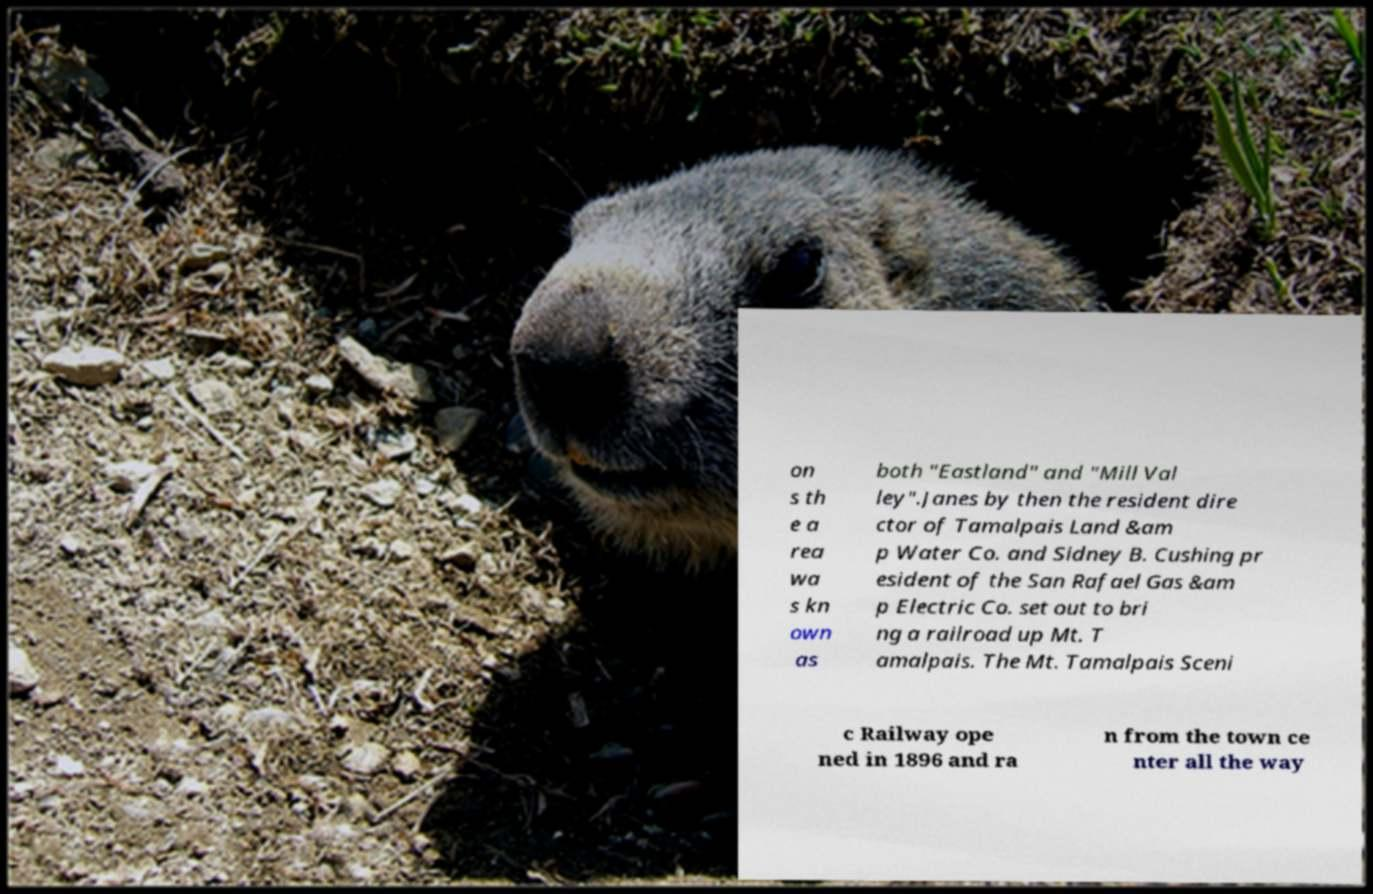Can you accurately transcribe the text from the provided image for me? on s th e a rea wa s kn own as both "Eastland" and "Mill Val ley".Janes by then the resident dire ctor of Tamalpais Land &am p Water Co. and Sidney B. Cushing pr esident of the San Rafael Gas &am p Electric Co. set out to bri ng a railroad up Mt. T amalpais. The Mt. Tamalpais Sceni c Railway ope ned in 1896 and ra n from the town ce nter all the way 